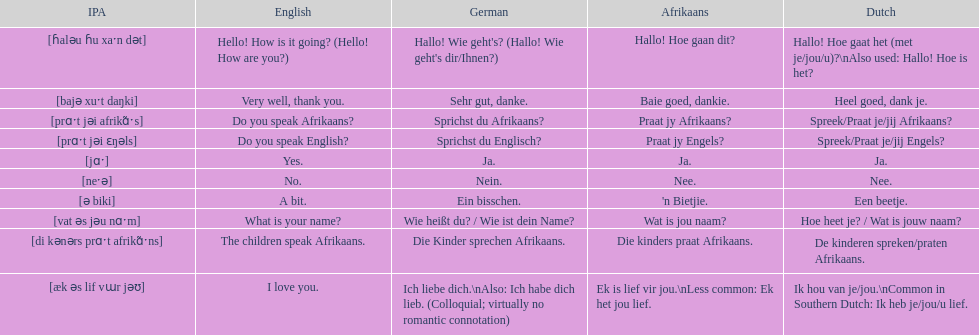How do you say 'do you speak afrikaans?' in afrikaans? Praat jy Afrikaans?. Would you be able to parse every entry in this table? {'header': ['IPA', 'English', 'German', 'Afrikaans', 'Dutch'], 'rows': [['[ɦaləu ɦu xaˑn dət]', 'Hello! How is it going? (Hello! How are you?)', "Hallo! Wie geht's? (Hallo! Wie geht's dir/Ihnen?)", 'Hallo! Hoe gaan dit?', 'Hallo! Hoe gaat het (met je/jou/u)?\\nAlso used: Hallo! Hoe is het?'], ['[bajə xuˑt daŋki]', 'Very well, thank you.', 'Sehr gut, danke.', 'Baie goed, dankie.', 'Heel goed, dank je.'], ['[prɑˑt jəi afrikɑ̃ˑs]', 'Do you speak Afrikaans?', 'Sprichst du Afrikaans?', 'Praat jy Afrikaans?', 'Spreek/Praat je/jij Afrikaans?'], ['[prɑˑt jəi ɛŋəls]', 'Do you speak English?', 'Sprichst du Englisch?', 'Praat jy Engels?', 'Spreek/Praat je/jij Engels?'], ['[jɑˑ]', 'Yes.', 'Ja.', 'Ja.', 'Ja.'], ['[neˑə]', 'No.', 'Nein.', 'Nee.', 'Nee.'], ['[ə biki]', 'A bit.', 'Ein bisschen.', "'n Bietjie.", 'Een beetje.'], ['[vat əs jəu nɑˑm]', 'What is your name?', 'Wie heißt du? / Wie ist dein Name?', 'Wat is jou naam?', 'Hoe heet je? / Wat is jouw naam?'], ['[di kənərs prɑˑt afrikɑ̃ˑns]', 'The children speak Afrikaans.', 'Die Kinder sprechen Afrikaans.', 'Die kinders praat Afrikaans.', 'De kinderen spreken/praten Afrikaans.'], ['[æk əs lif vɯr jəʊ]', 'I love you.', 'Ich liebe dich.\\nAlso: Ich habe dich lieb. (Colloquial; virtually no romantic connotation)', 'Ek is lief vir jou.\\nLess common: Ek het jou lief.', 'Ik hou van je/jou.\\nCommon in Southern Dutch: Ik heb je/jou/u lief.']]} 